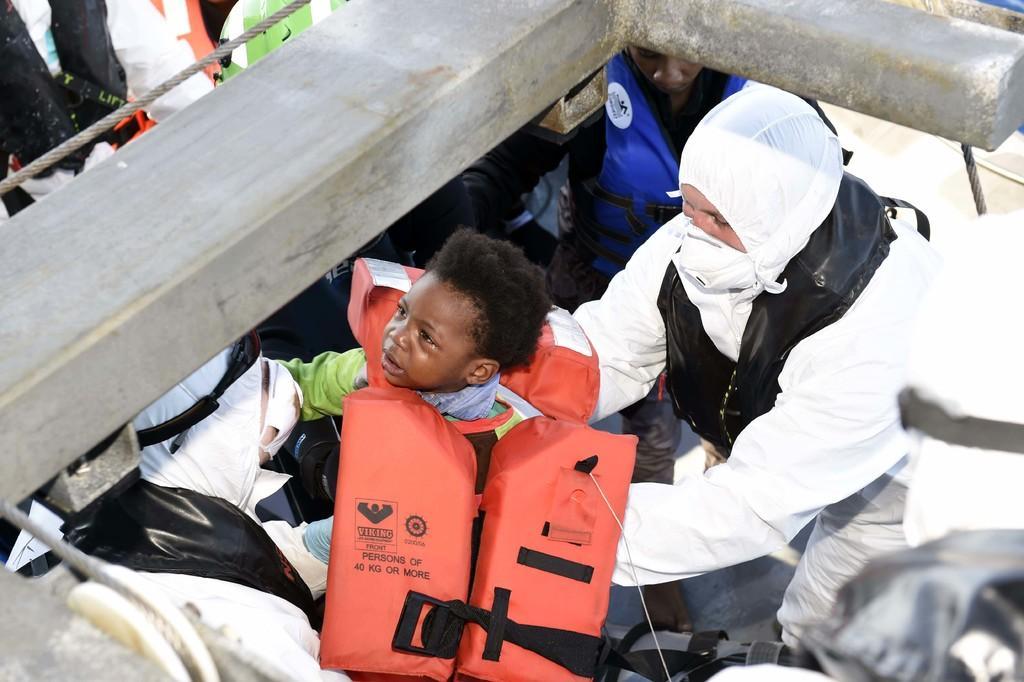Please provide a concise description of this image. In this image we can see few people, a kid is with life jacket and a person is wearing a mask and there is an object and a rope. 